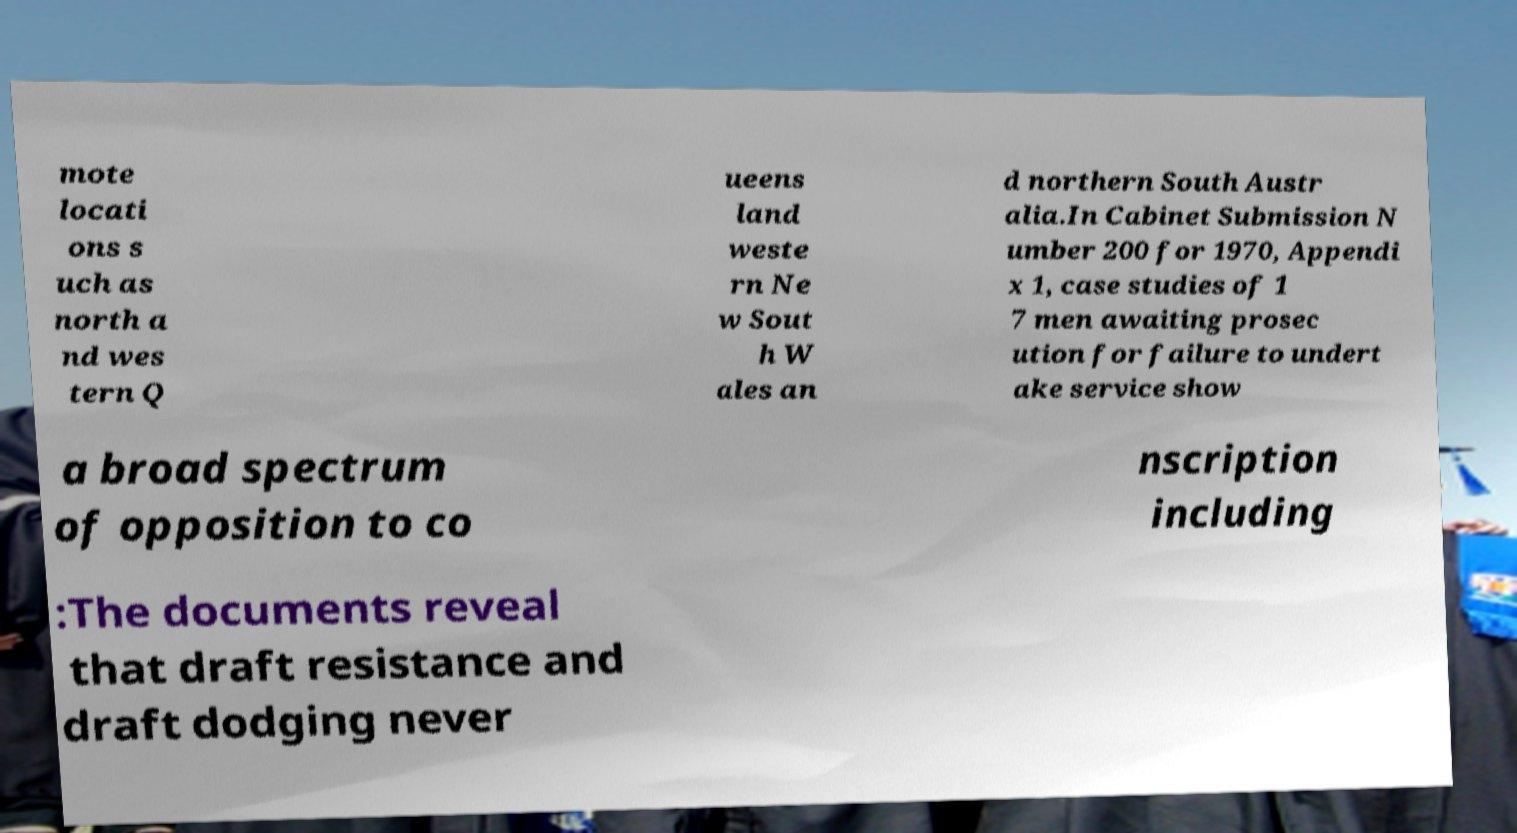Could you extract and type out the text from this image? mote locati ons s uch as north a nd wes tern Q ueens land weste rn Ne w Sout h W ales an d northern South Austr alia.In Cabinet Submission N umber 200 for 1970, Appendi x 1, case studies of 1 7 men awaiting prosec ution for failure to undert ake service show a broad spectrum of opposition to co nscription including :The documents reveal that draft resistance and draft dodging never 